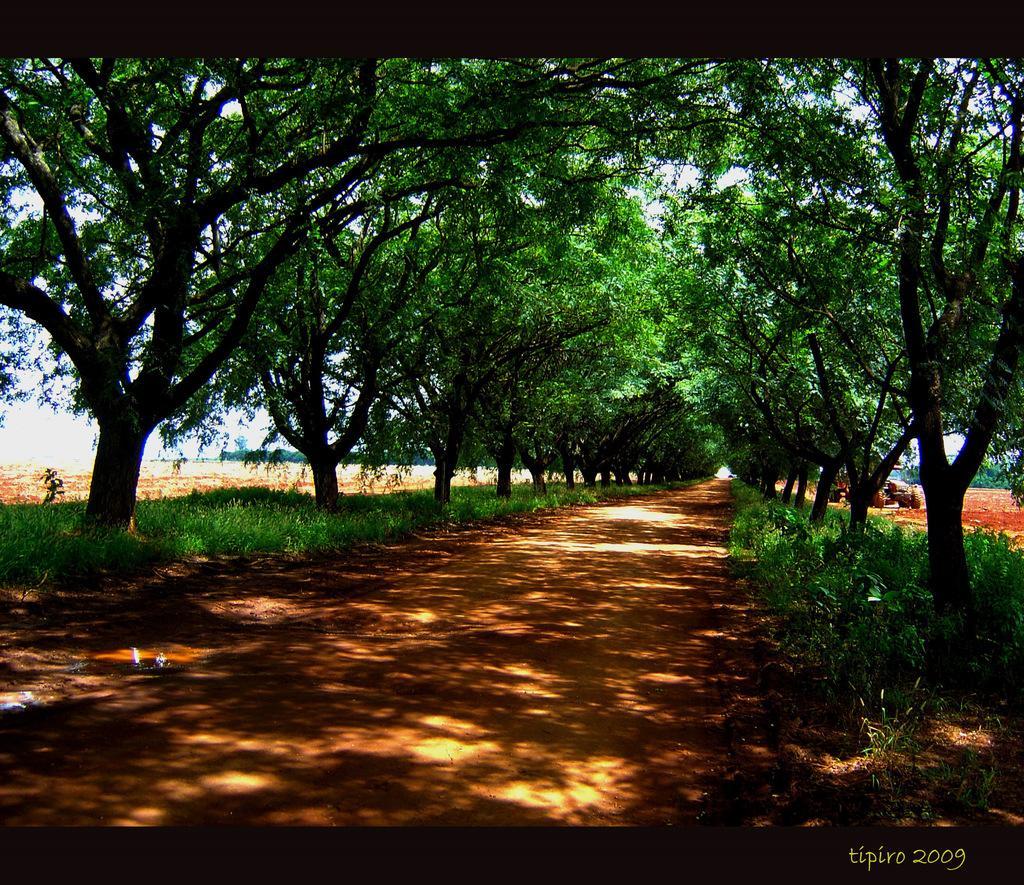Can you describe this image briefly? At the bottom of this image there is a path. On both sides, I can see the grass and trees. In the bottom right-hand corner there is some text. 